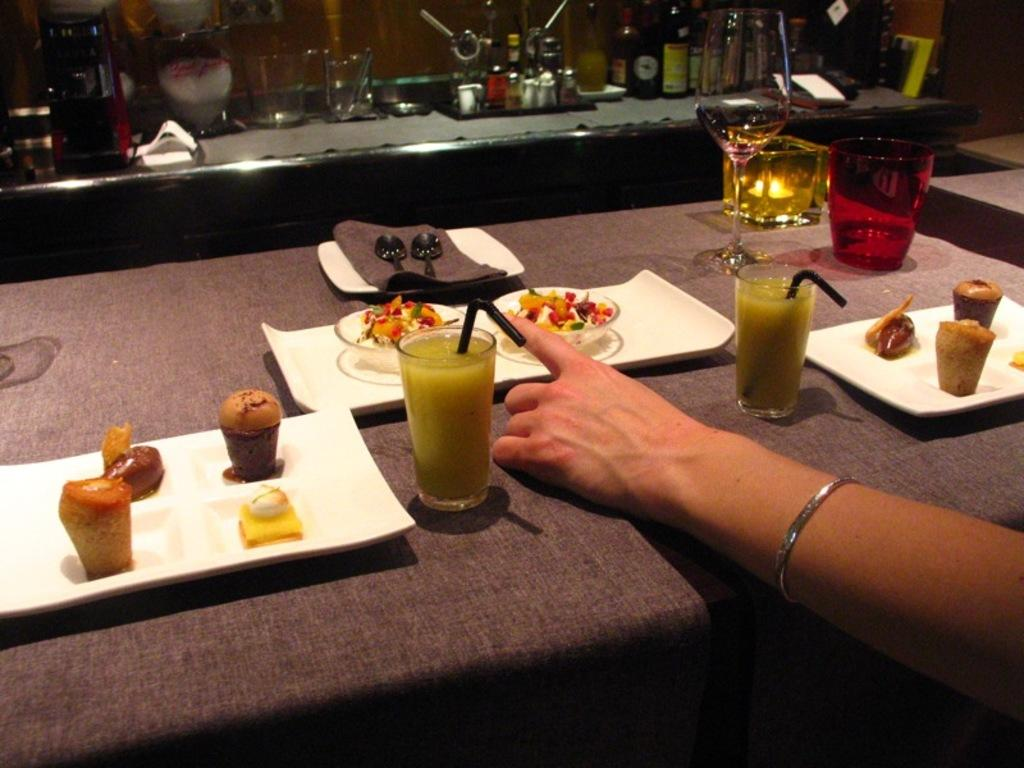What is placed on the table in the image? There is a plate on the table. What else can be seen on the table? There is food, a glass, and a spoon on the table. Are there any other items visible in the image? Yes, there are bottles visible at the back side. What type of statement can be seen on the table in the image? There is no statement visible on the table in the image. Can you tell me how the heat is being generated in the image? There is no heat generation visible in the image. 